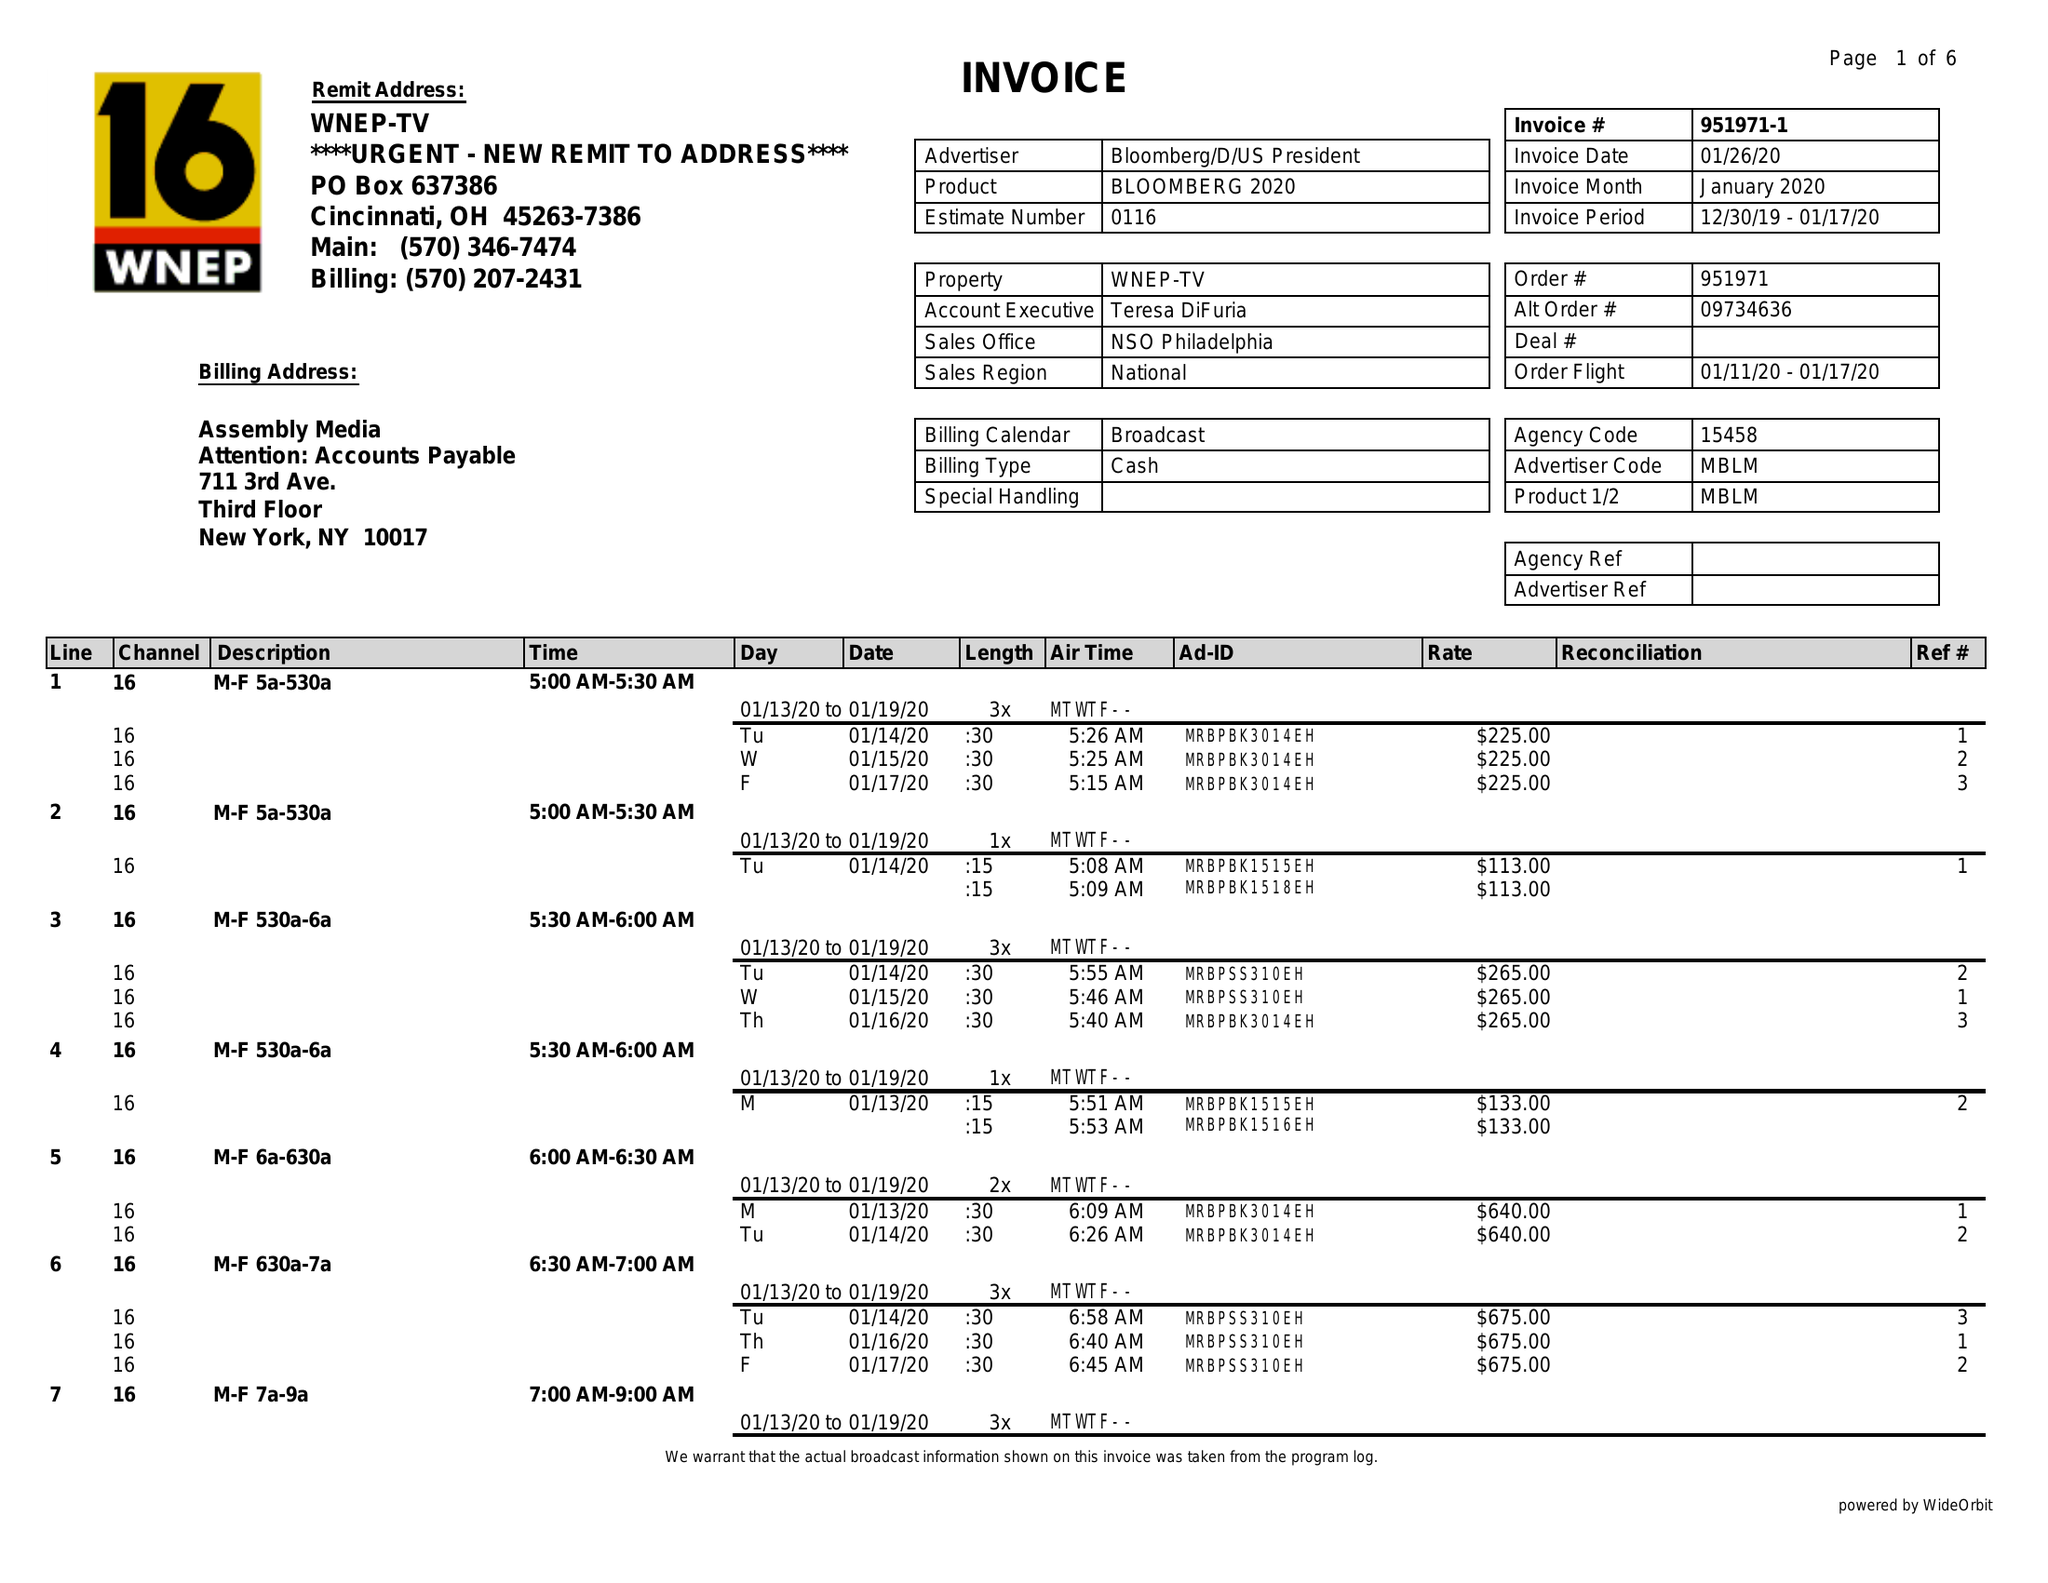What is the value for the contract_num?
Answer the question using a single word or phrase. 951971 